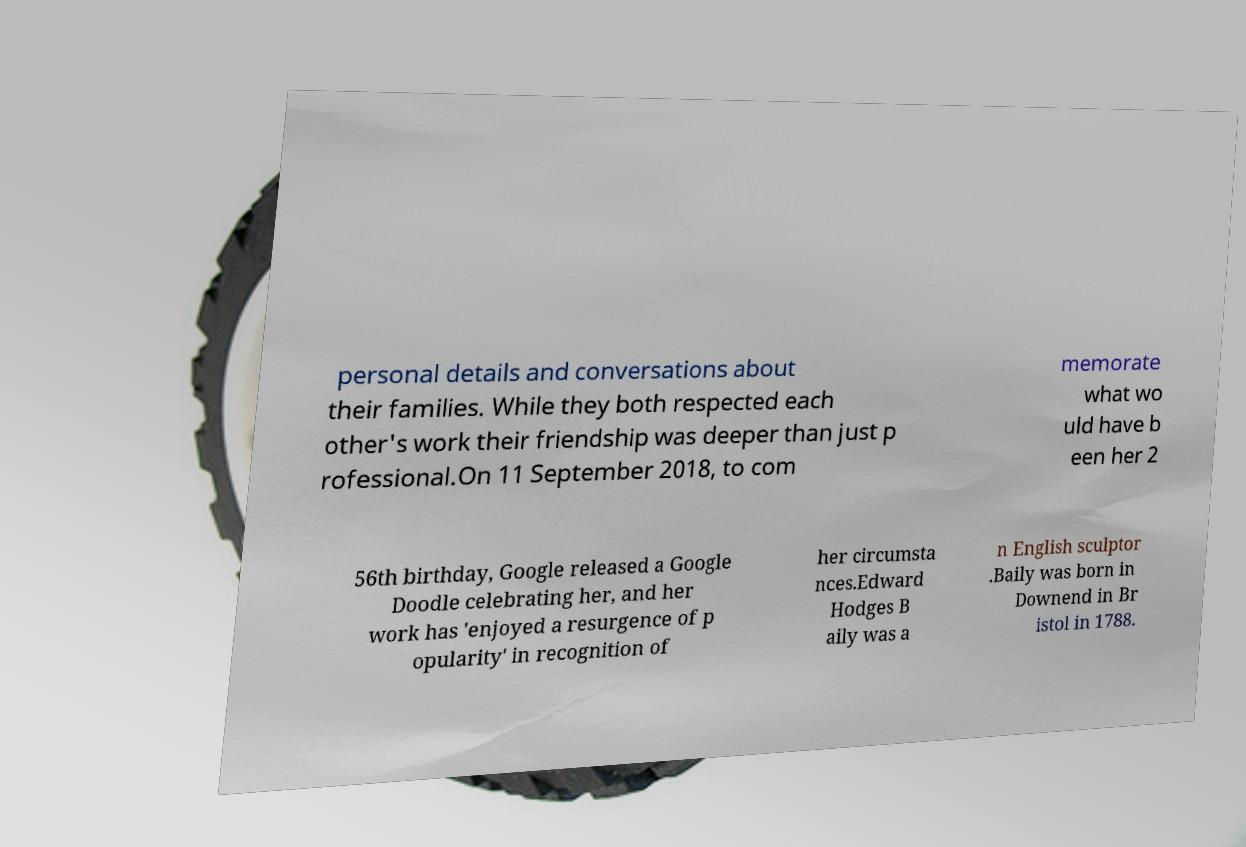There's text embedded in this image that I need extracted. Can you transcribe it verbatim? personal details and conversations about their families. While they both respected each other's work their friendship was deeper than just p rofessional.On 11 September 2018, to com memorate what wo uld have b een her 2 56th birthday, Google released a Google Doodle celebrating her, and her work has 'enjoyed a resurgence of p opularity' in recognition of her circumsta nces.Edward Hodges B aily was a n English sculptor .Baily was born in Downend in Br istol in 1788. 